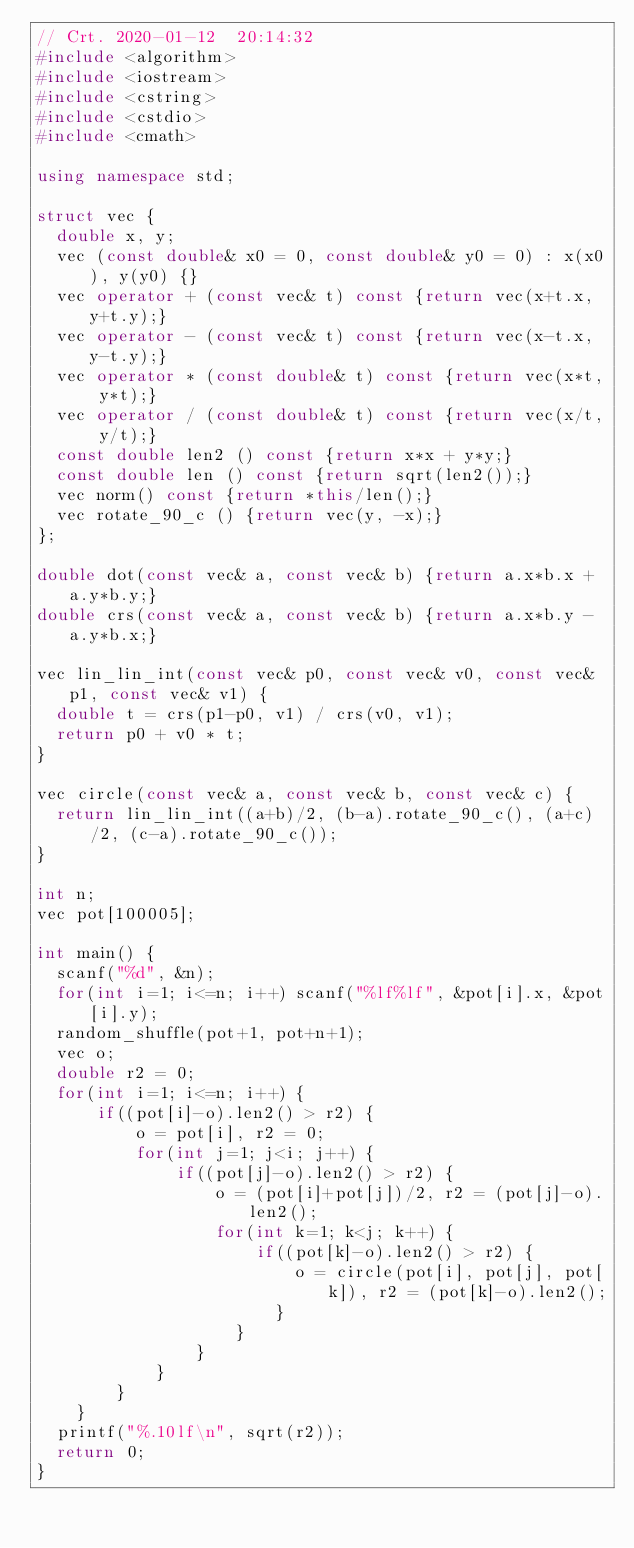<code> <loc_0><loc_0><loc_500><loc_500><_C++_>// Crt. 2020-01-12  20:14:32
#include <algorithm>
#include <iostream>
#include <cstring>
#include <cstdio>
#include <cmath>

using namespace std;

struct vec {
  double x, y;
  vec (const double& x0 = 0, const double& y0 = 0) : x(x0), y(y0) {}
  vec operator + (const vec& t) const {return vec(x+t.x, y+t.y);}
  vec operator - (const vec& t) const {return vec(x-t.x, y-t.y);}
  vec operator * (const double& t) const {return vec(x*t, y*t);}
  vec operator / (const double& t) const {return vec(x/t, y/t);}
  const double len2 () const {return x*x + y*y;}
  const double len () const {return sqrt(len2());}
  vec norm() const {return *this/len();}
  vec rotate_90_c () {return vec(y, -x);}
};

double dot(const vec& a, const vec& b) {return a.x*b.x + a.y*b.y;}
double crs(const vec& a, const vec& b) {return a.x*b.y - a.y*b.x;}

vec lin_lin_int(const vec& p0, const vec& v0, const vec& p1, const vec& v1) {
  double t = crs(p1-p0, v1) / crs(v0, v1);
  return p0 + v0 * t;
}

vec circle(const vec& a, const vec& b, const vec& c) {
  return lin_lin_int((a+b)/2, (b-a).rotate_90_c(), (a+c)/2, (c-a).rotate_90_c());
}

int n;
vec pot[100005];

int main() {
  scanf("%d", &n);
  for(int i=1; i<=n; i++) scanf("%lf%lf", &pot[i].x, &pot[i].y);
  random_shuffle(pot+1, pot+n+1);
  vec o;
  double r2 = 0;
  for(int i=1; i<=n; i++) {
      if((pot[i]-o).len2() > r2) {
          o = pot[i], r2 = 0;
          for(int j=1; j<i; j++) {
              if((pot[j]-o).len2() > r2) {
                  o = (pot[i]+pot[j])/2, r2 = (pot[j]-o).len2();
                  for(int k=1; k<j; k++) {
                      if((pot[k]-o).len2() > r2) {
                          o = circle(pot[i], pot[j], pot[k]), r2 = (pot[k]-o).len2();
                        }
                    }
                }
            }
        }
    }
  printf("%.10lf\n", sqrt(r2));
  return 0;
}

</code> 